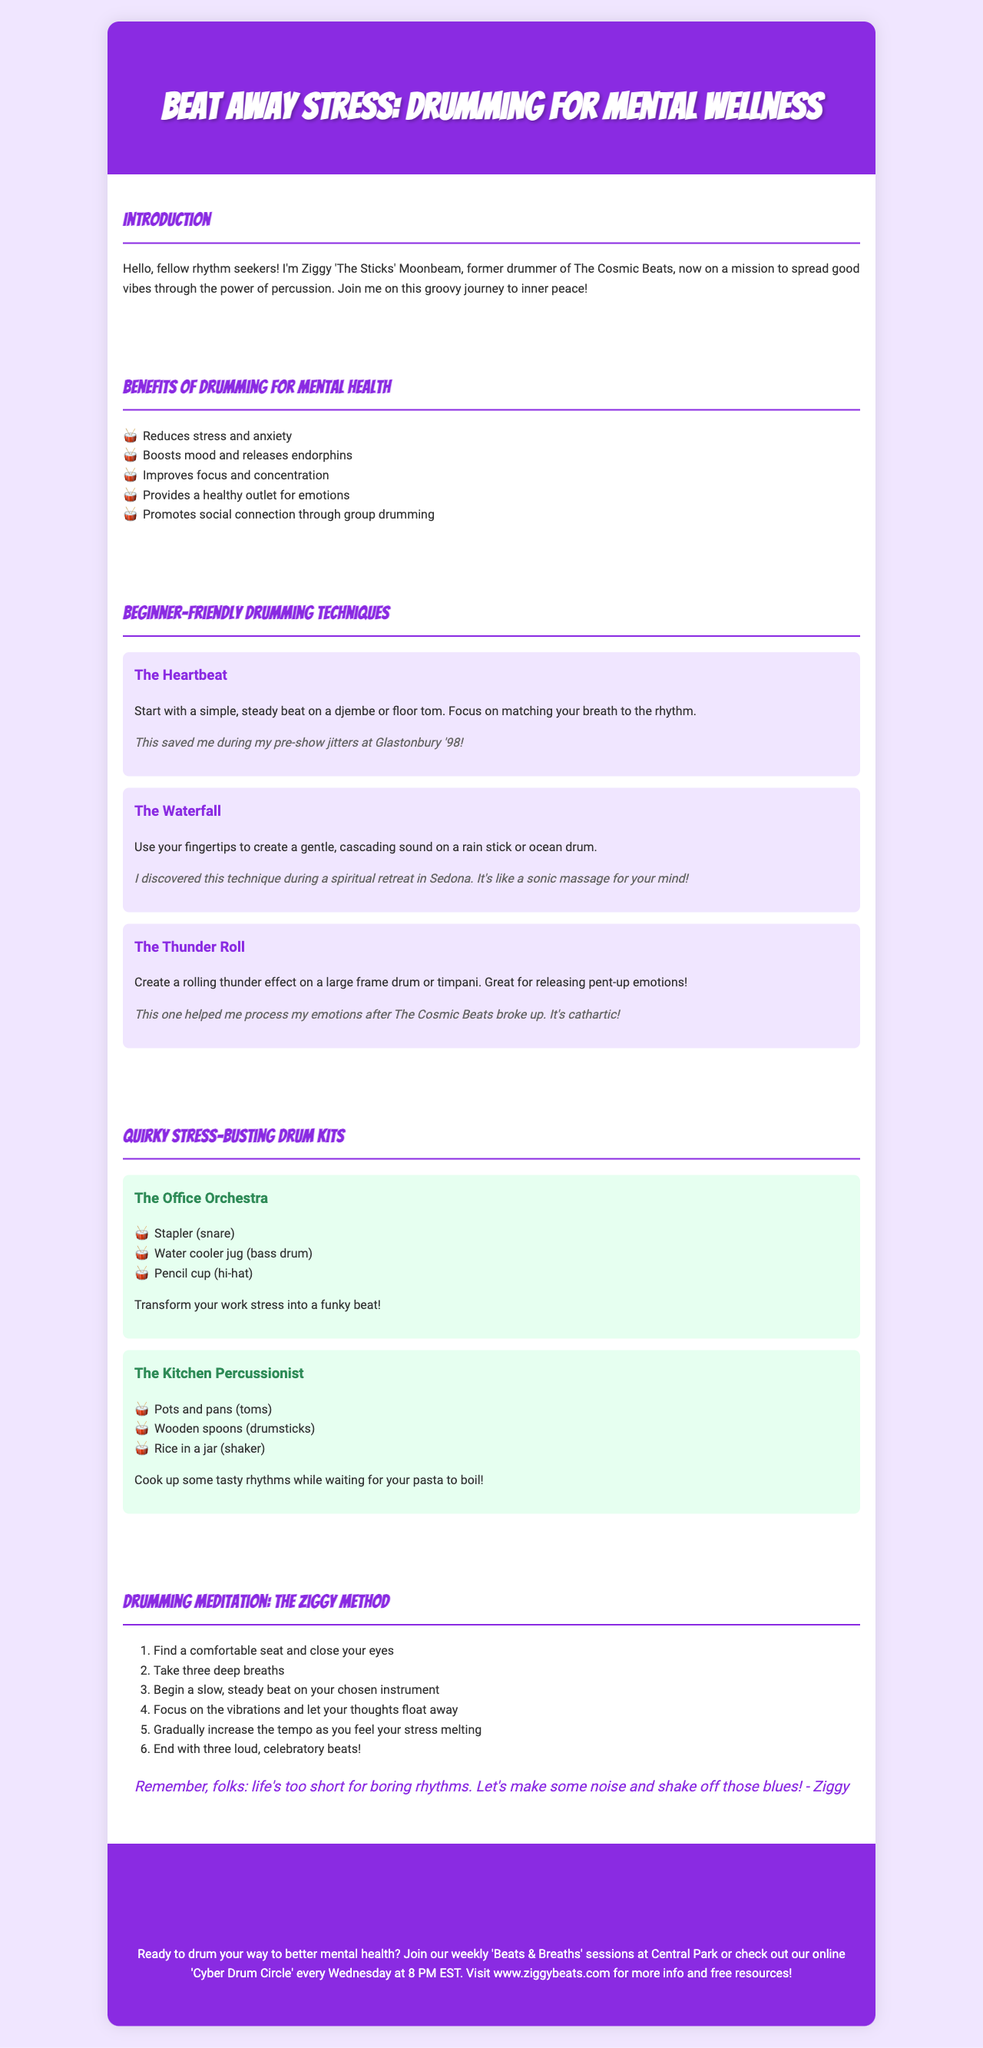what is the title of the brochure? The title is mentioned at the top of the document as the main heading.
Answer: Beat Away Stress: Drumming for Mental Wellness who is Ziggy Moonbeam? Ziggy is the author and the narrator of the brochure, introducing himself to the readers.
Answer: Ziggy 'The Sticks' Moonbeam how many benefits of drumming for mental health are listed? The brochure provides a specific list of benefits in the "Benefits of Drumming for Mental Health" section.
Answer: five what is the first beginner-friendly drumming technique mentioned? The first technique is introduced in the section dedicated to beginner-friendly techniques.
Answer: The Heartbeat what items are included in "The Kitchen Percussionist" kit? The brochure details the items used in this quirky drum kit for home use.
Answer: Pots and pans, Wooden spoons, Rice in a jar how does the ziggy method start? This refers to the first step in the Drumming Meditation section outlined in the brochure.
Answer: Find a comfortable seat and close your eyes what does the quote at the end of the meditation section emphasize? The quote encapsulates the philosophy behind Ziggy's drumming meditation approach.
Answer: life's too short for boring rhythms how can one join the weekly sessions mentioned in the brochure? This information is in the section regarding participation in the "Beats & Breaths" sessions.
Answer: Visit www.ziggybeats.com for more info 